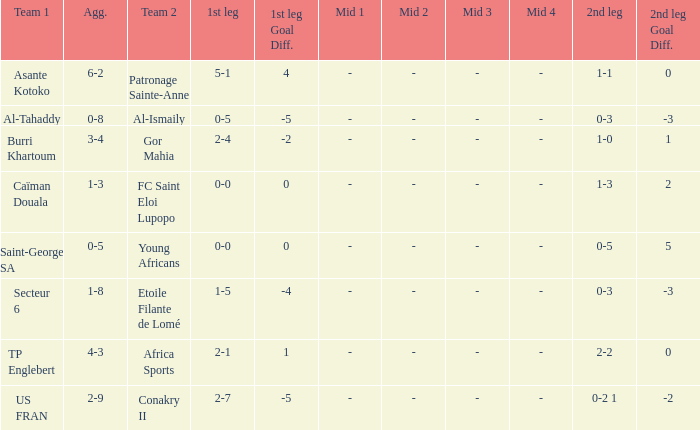Which teams had an aggregate score of 3-4? Burri Khartoum. 